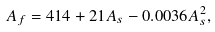Convert formula to latex. <formula><loc_0><loc_0><loc_500><loc_500>A _ { f } = 4 1 4 + 2 1 A _ { s } - 0 . 0 0 3 6 A _ { s } ^ { 2 } ,</formula> 